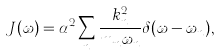<formula> <loc_0><loc_0><loc_500><loc_500>J ( \omega ) = \alpha ^ { 2 } \sum _ { n } \frac { k _ { n } ^ { 2 } } { m _ { n } \omega _ { n } } \delta ( \omega - \omega _ { n } ) ,</formula> 